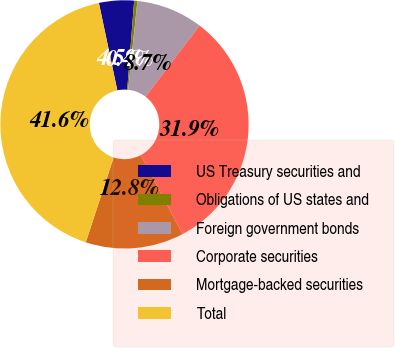Convert chart. <chart><loc_0><loc_0><loc_500><loc_500><pie_chart><fcel>US Treasury securities and<fcel>Obligations of US states and<fcel>Foreign government bonds<fcel>Corporate securities<fcel>Mortgage-backed securities<fcel>Total<nl><fcel>4.55%<fcel>0.42%<fcel>8.67%<fcel>31.93%<fcel>12.79%<fcel>41.65%<nl></chart> 